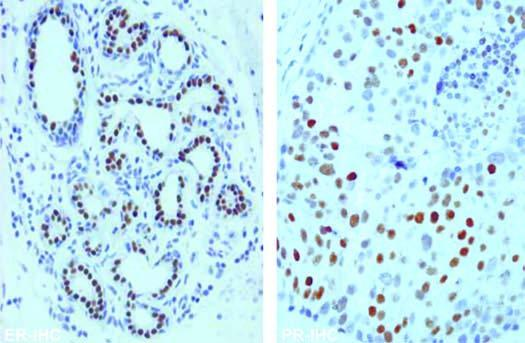what do the tumour cells show with er and pr antibody immunostains?
Answer the question using a single word or phrase. Nuclear positivity 